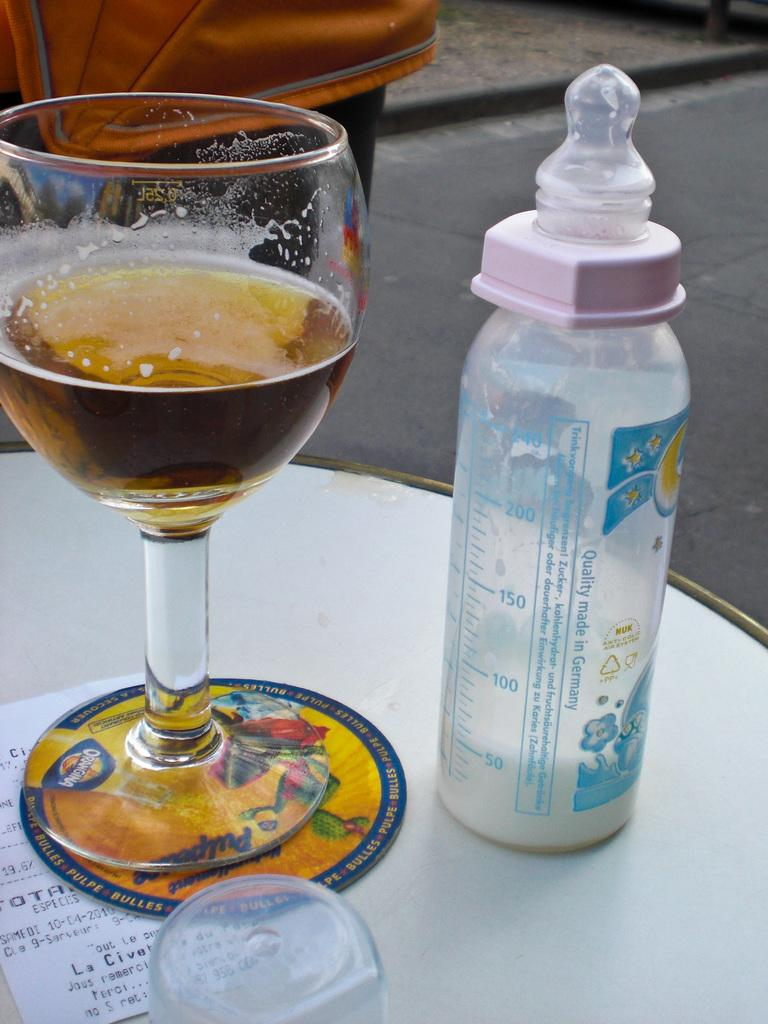What type of furniture is present in the image? There is a table in the image. What objects are on the table? There is a bottle filled with a liquid, a glass filled with a liquid, and a paper on the table. Can you see your mom in the image? There is no person, including your mom, present in the image. The image only shows a table with objects on it. 